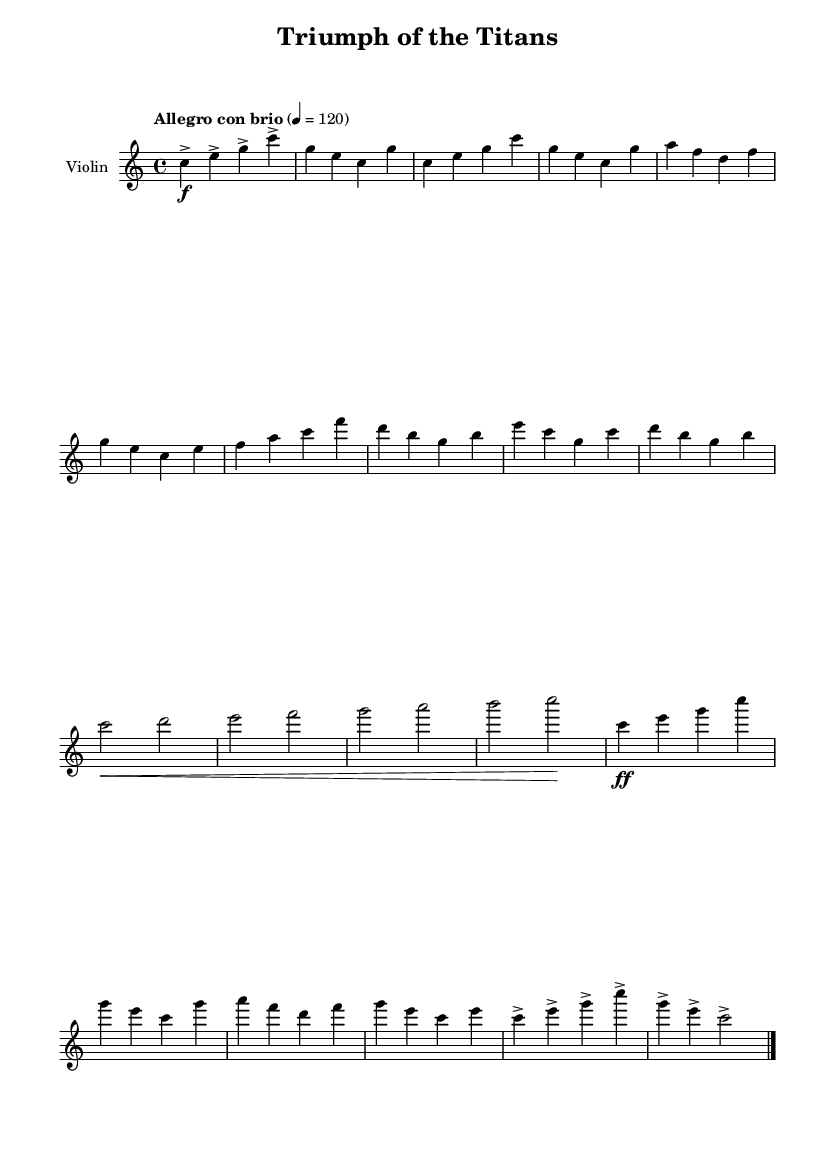What is the key signature of this music? The key signature is C major, which has no sharps or flats.
Answer: C major What is the time signature of this music? The time signature is indicated at the beginning of the score and it is 4/4, meaning there are four beats per measure.
Answer: 4/4 What is the tempo marking for this composition? The tempo marking is provided as "Allegro con brio", indicating a lively and brisk pace.
Answer: Allegro con brio How many main themes are present in this piece? The piece has two distinct main themes labeled as Theme A and Theme B, as seen in different sections of the music.
Answer: 2 What instruments are indicated in the score? The score specifies the instrument as "Violin", which is the only instrument featured in this particular composition.
Answer: Violin What dynamics are used at the beginning of Theme A? The beginning of Theme A utilizes a forte dynamic marking, indicated by the symbol 'f' before the notes.
Answer: Forte Describe the function of the bridge in this piece. The bridge serves as a transition between themes, creating contrast and leading back into Theme A, while introducing new notes and dynamics.
Answer: Transition 